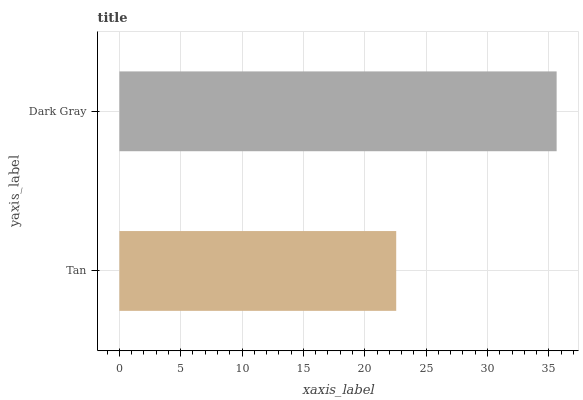Is Tan the minimum?
Answer yes or no. Yes. Is Dark Gray the maximum?
Answer yes or no. Yes. Is Dark Gray the minimum?
Answer yes or no. No. Is Dark Gray greater than Tan?
Answer yes or no. Yes. Is Tan less than Dark Gray?
Answer yes or no. Yes. Is Tan greater than Dark Gray?
Answer yes or no. No. Is Dark Gray less than Tan?
Answer yes or no. No. Is Dark Gray the high median?
Answer yes or no. Yes. Is Tan the low median?
Answer yes or no. Yes. Is Tan the high median?
Answer yes or no. No. Is Dark Gray the low median?
Answer yes or no. No. 